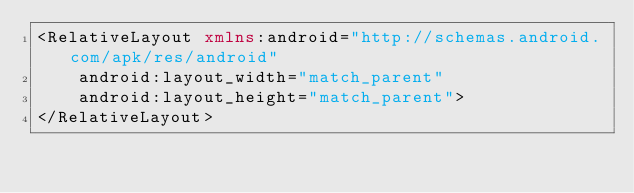Convert code to text. <code><loc_0><loc_0><loc_500><loc_500><_XML_><RelativeLayout xmlns:android="http://schemas.android.com/apk/res/android"
    android:layout_width="match_parent"
    android:layout_height="match_parent">
</RelativeLayout></code> 